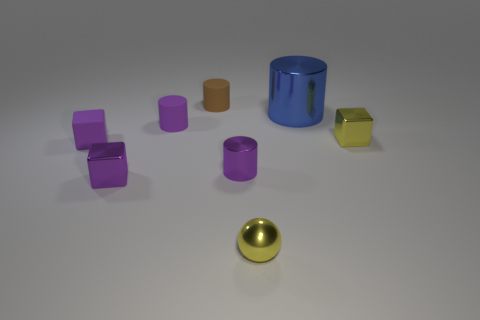Is there anything else that is the same size as the blue thing?
Give a very brief answer. No. What material is the tiny brown cylinder?
Your answer should be compact. Rubber. What shape is the yellow metallic thing that is on the right side of the small yellow thing on the left side of the blue metal cylinder?
Keep it short and to the point. Cube. There is a yellow thing that is in front of the small purple metallic cylinder; what is its shape?
Give a very brief answer. Sphere. How many large cubes have the same color as the small metal cylinder?
Your answer should be very brief. 0. The matte cube has what color?
Give a very brief answer. Purple. What number of tiny purple rubber blocks are left of the small metallic block that is on the left side of the shiny sphere?
Offer a very short reply. 1. There is a sphere; is its size the same as the purple shiny cube on the left side of the yellow cube?
Provide a short and direct response. Yes. Is the size of the rubber block the same as the blue shiny cylinder?
Give a very brief answer. No. Is there a blue cylinder of the same size as the yellow cube?
Give a very brief answer. No. 